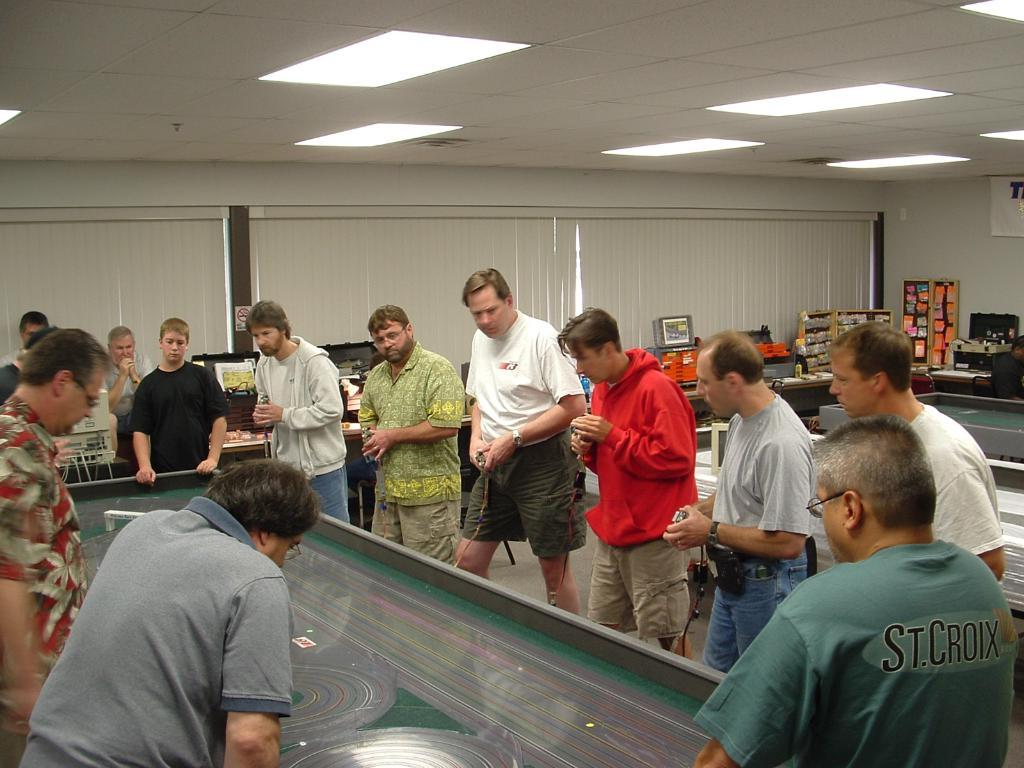How many people are in the room in the image? There is a group of men in the room. What are the men doing in the image? The men are standing near a table and staring at something. What can be seen in the room besides the men and table? There are lights, curtains, and a desk in the room. How many houses are visible in the image? There are no houses visible in the image; it shows a group of men in a room. What type of authority figure is present in the image? There is no authority figure present in the image; it shows a group of men in a room. 